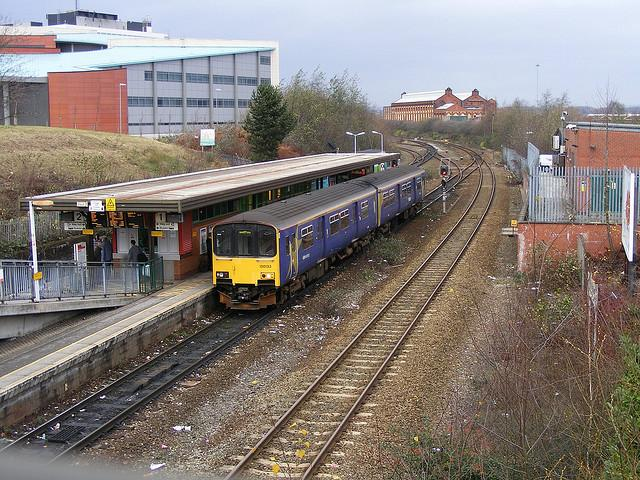At which building does the purple train stop? Please explain your reasoning. depot. A train is stopped at a small building along the tracks. places along train tracks for people to board have a place to buy tickets and wait for the train out of the weather. 